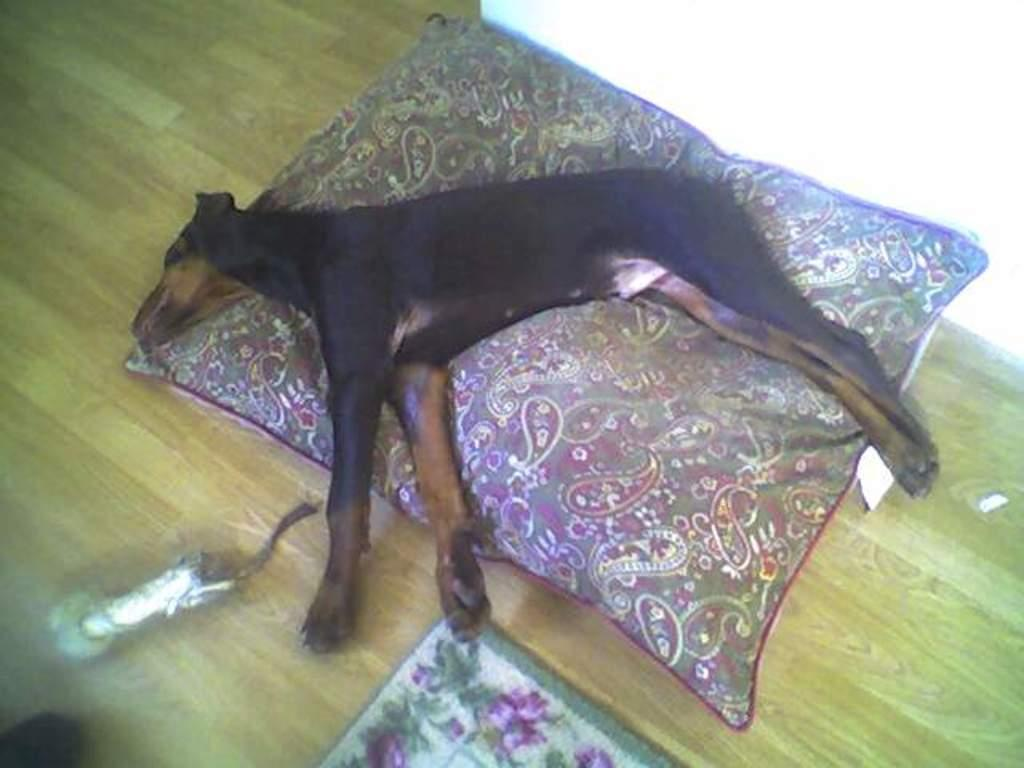What type of animal is in the image? There is a black dog in the image. What is the dog doing in the image? The dog is laying on a pillow. Where is the pillow located? The pillow is on a wooden floor. What is in front of the dog? There is a mat in front of the dog. What is behind the dog? There is a wall behind the dog. What type of brass instrument is the dog playing in the image? There is no brass instrument present in the image; it features a black dog laying on a pillow. Can you see the dog giving a kiss to someone in the image? There is no indication of the dog giving a kiss to someone in the image. 